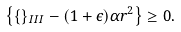Convert formula to latex. <formula><loc_0><loc_0><loc_500><loc_500>\left \{ \{ \} _ { I I I } - ( 1 + \epsilon ) \alpha r ^ { 2 } \right \} \geq 0 .</formula> 